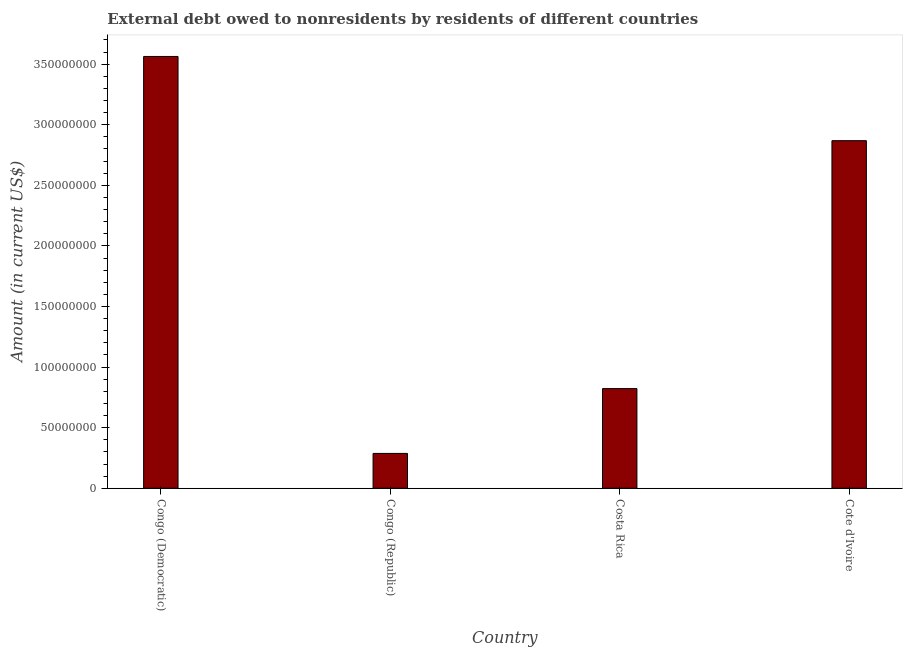Does the graph contain any zero values?
Provide a short and direct response. No. What is the title of the graph?
Your response must be concise. External debt owed to nonresidents by residents of different countries. What is the debt in Congo (Republic)?
Provide a succinct answer. 2.88e+07. Across all countries, what is the maximum debt?
Ensure brevity in your answer.  3.56e+08. Across all countries, what is the minimum debt?
Offer a terse response. 2.88e+07. In which country was the debt maximum?
Your answer should be compact. Congo (Democratic). In which country was the debt minimum?
Your answer should be compact. Congo (Republic). What is the sum of the debt?
Offer a terse response. 7.54e+08. What is the difference between the debt in Congo (Democratic) and Costa Rica?
Your answer should be compact. 2.74e+08. What is the average debt per country?
Offer a terse response. 1.89e+08. What is the median debt?
Give a very brief answer. 1.85e+08. Is the debt in Congo (Democratic) less than that in Congo (Republic)?
Provide a short and direct response. No. What is the difference between the highest and the second highest debt?
Offer a terse response. 6.95e+07. What is the difference between the highest and the lowest debt?
Your answer should be compact. 3.28e+08. How many bars are there?
Provide a succinct answer. 4. How many countries are there in the graph?
Keep it short and to the point. 4. What is the Amount (in current US$) in Congo (Democratic)?
Offer a terse response. 3.56e+08. What is the Amount (in current US$) of Congo (Republic)?
Offer a terse response. 2.88e+07. What is the Amount (in current US$) in Costa Rica?
Make the answer very short. 8.23e+07. What is the Amount (in current US$) of Cote d'Ivoire?
Provide a short and direct response. 2.87e+08. What is the difference between the Amount (in current US$) in Congo (Democratic) and Congo (Republic)?
Provide a short and direct response. 3.28e+08. What is the difference between the Amount (in current US$) in Congo (Democratic) and Costa Rica?
Offer a very short reply. 2.74e+08. What is the difference between the Amount (in current US$) in Congo (Democratic) and Cote d'Ivoire?
Your answer should be very brief. 6.95e+07. What is the difference between the Amount (in current US$) in Congo (Republic) and Costa Rica?
Offer a terse response. -5.35e+07. What is the difference between the Amount (in current US$) in Congo (Republic) and Cote d'Ivoire?
Make the answer very short. -2.58e+08. What is the difference between the Amount (in current US$) in Costa Rica and Cote d'Ivoire?
Your answer should be compact. -2.05e+08. What is the ratio of the Amount (in current US$) in Congo (Democratic) to that in Congo (Republic)?
Give a very brief answer. 12.39. What is the ratio of the Amount (in current US$) in Congo (Democratic) to that in Costa Rica?
Provide a short and direct response. 4.33. What is the ratio of the Amount (in current US$) in Congo (Democratic) to that in Cote d'Ivoire?
Your response must be concise. 1.24. What is the ratio of the Amount (in current US$) in Congo (Republic) to that in Costa Rica?
Offer a very short reply. 0.35. What is the ratio of the Amount (in current US$) in Costa Rica to that in Cote d'Ivoire?
Offer a terse response. 0.29. 